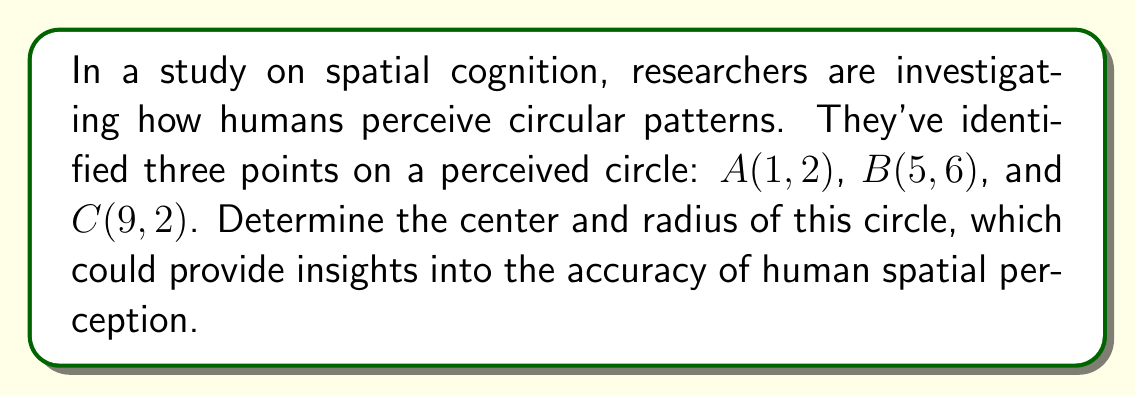Provide a solution to this math problem. Let's approach this step-by-step:

1) To find the center of the circle, we need to find the perpendicular bisectors of any two chords. The intersection of these bisectors will be the center.

2) Let's choose chords AB and BC. We'll find their midpoints first:

   Midpoint of AB: $M_1 = (\frac{1+5}{2}, \frac{2+6}{2}) = (3, 4)$
   Midpoint of BC: $M_2 = (\frac{5+9}{2}, \frac{6+2}{2}) = (7, 4)$

3) Now, let's find the slopes of AB and BC:

   Slope of AB: $m_{AB} = \frac{6-2}{5-1} = 1$
   Slope of BC: $m_{BC} = \frac{2-6}{9-5} = -1$

4) The slopes of the perpendicular bisectors will be the negative reciprocals:

   Slope of AB's bisector: $m_1 = -\frac{1}{1} = -1$
   Slope of BC's bisector: $m_2 = -\frac{1}{-1} = 1$

5) We can now write equations for these bisectors:

   AB's bisector: $y - 4 = -1(x - 3)$ or $y = -x + 7$
   BC's bisector: $y - 4 = 1(x - 7)$ or $y = x - 3$

6) To find the center, we solve these equations simultaneously:

   $-x + 7 = x - 3$
   $2x = 10$
   $x = 5$

   Substituting back: $y = 5 - 3 = 2$

   So, the center is at $(5, 2)$.

7) To find the radius, we can calculate the distance from the center to any of the given points. Let's use point A:

   $r = \sqrt{(5-1)^2 + (2-2)^2} = \sqrt{16 + 0} = 4$

Therefore, the center is at $(5, 2)$ and the radius is 4.
Answer: Center: $(5, 2)$, Radius: $4$ 